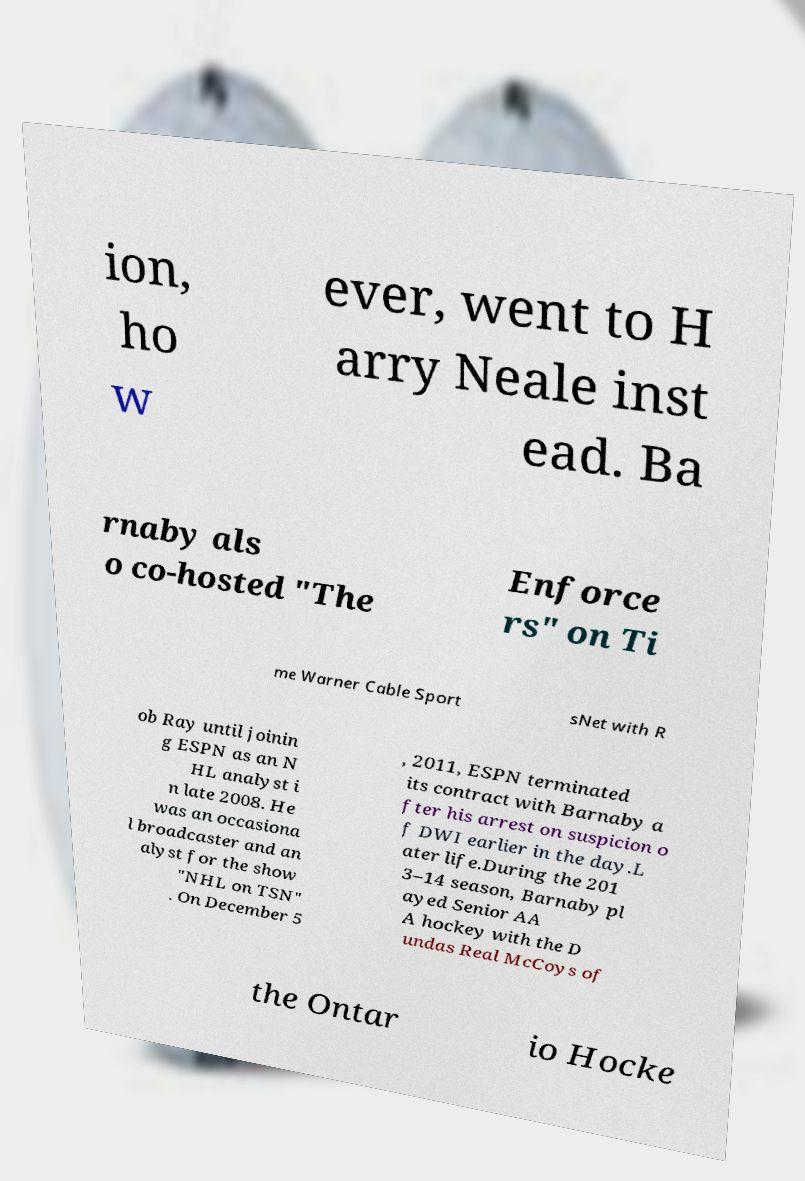Can you accurately transcribe the text from the provided image for me? ion, ho w ever, went to H arry Neale inst ead. Ba rnaby als o co-hosted "The Enforce rs" on Ti me Warner Cable Sport sNet with R ob Ray until joinin g ESPN as an N HL analyst i n late 2008. He was an occasiona l broadcaster and an alyst for the show "NHL on TSN" . On December 5 , 2011, ESPN terminated its contract with Barnaby a fter his arrest on suspicion o f DWI earlier in the day.L ater life.During the 201 3–14 season, Barnaby pl ayed Senior AA A hockey with the D undas Real McCoys of the Ontar io Hocke 